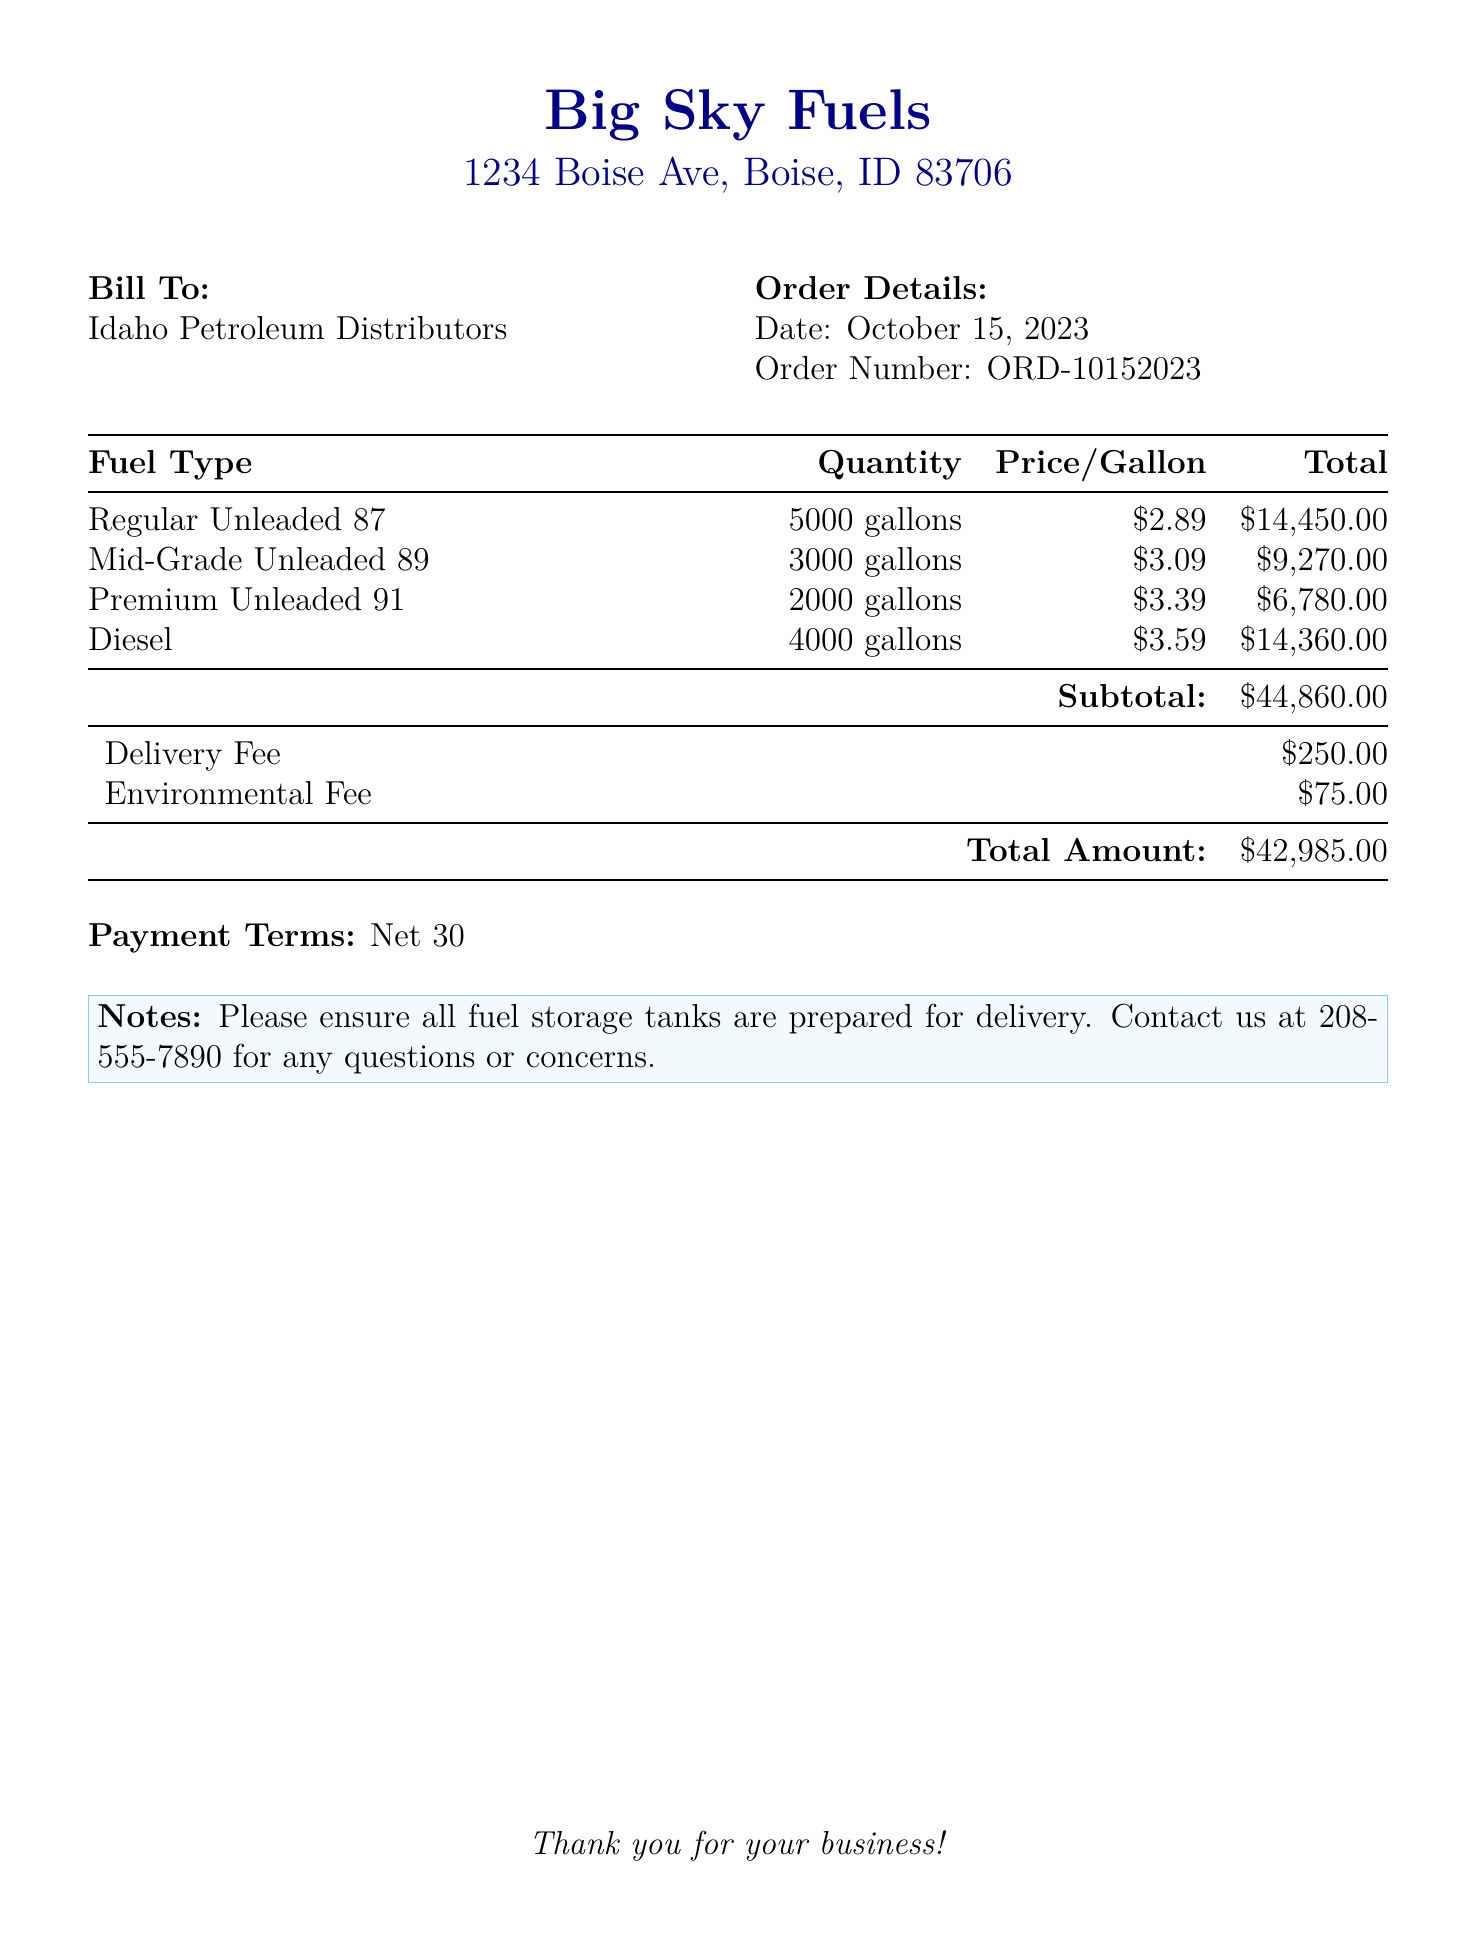What is the order date? The order date is specified in the document as October 15, 2023.
Answer: October 15, 2023 What is the price per gallon of Premium Unleaded 91? The price per gallon of Premium Unleaded 91 is listed in the document.
Answer: $3.39 How many gallons of Mid-Grade Unleaded 89 were ordered? The quantity ordered for Mid-Grade Unleaded 89 is mentioned in the inventory section.
Answer: 3000 gallons What is the total amount due for this order? The total amount is summarized at the bottom of the bill.
Answer: $42,985.00 What is the subtotal before additional fees? The subtotal is calculated before adding the delivery and environmental fees.
Answer: $44,860.00 What is the Environmental Fee listed in the bill? The Environmental Fee is detailed in the additional charges section of the document.
Answer: $75.00 How many gallons of Diesel were ordered? The document specifies the quantity of Diesel ordered in the table of fuel types.
Answer: 4000 gallons What are the payment terms for this invoice? The payment terms are clearly stated at the bottom of the document.
Answer: Net 30 What telephone number can be contacted for questions? The contact number for inquiries is provided in the notes section of the document.
Answer: 208-555-7890 